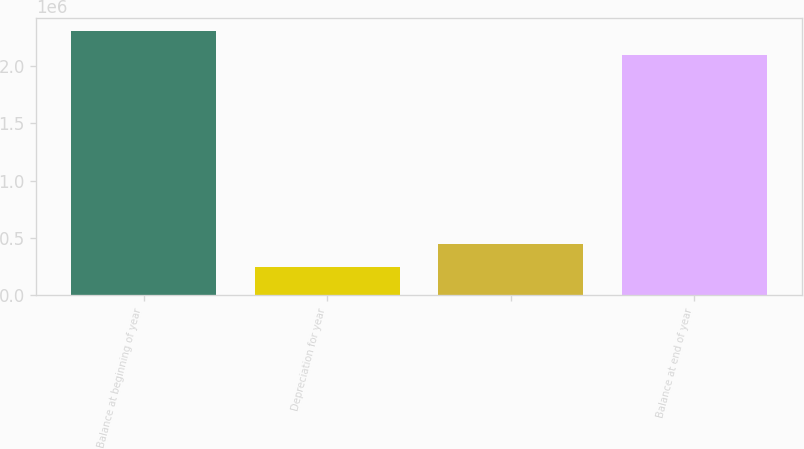Convert chart. <chart><loc_0><loc_0><loc_500><loc_500><bar_chart><fcel>Balance at beginning of year<fcel>Depreciation for year<fcel>Unnamed: 2<fcel>Balance at end of year<nl><fcel>2.30465e+06<fcel>245033<fcel>450541<fcel>2.09914e+06<nl></chart> 